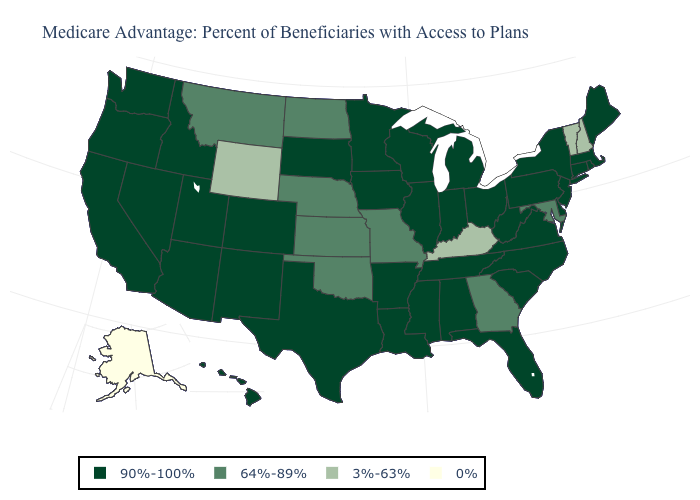Name the states that have a value in the range 0%?
Keep it brief. Alaska. What is the value of Massachusetts?
Quick response, please. 90%-100%. Name the states that have a value in the range 0%?
Short answer required. Alaska. What is the lowest value in the South?
Answer briefly. 3%-63%. Among the states that border Michigan , which have the lowest value?
Keep it brief. Indiana, Ohio, Wisconsin. Name the states that have a value in the range 90%-100%?
Keep it brief. Alabama, Arkansas, Arizona, California, Colorado, Connecticut, Delaware, Florida, Hawaii, Iowa, Idaho, Illinois, Indiana, Louisiana, Massachusetts, Maine, Michigan, Minnesota, Mississippi, North Carolina, New Jersey, New Mexico, Nevada, New York, Ohio, Oregon, Pennsylvania, Rhode Island, South Carolina, South Dakota, Tennessee, Texas, Utah, Virginia, Washington, Wisconsin, West Virginia. What is the value of South Carolina?
Short answer required. 90%-100%. Does the first symbol in the legend represent the smallest category?
Be succinct. No. Name the states that have a value in the range 64%-89%?
Write a very short answer. Georgia, Kansas, Maryland, Missouri, Montana, North Dakota, Nebraska, Oklahoma. Does California have the lowest value in the USA?
Write a very short answer. No. How many symbols are there in the legend?
Be succinct. 4. Is the legend a continuous bar?
Quick response, please. No. What is the lowest value in the USA?
Concise answer only. 0%. Name the states that have a value in the range 90%-100%?
Short answer required. Alabama, Arkansas, Arizona, California, Colorado, Connecticut, Delaware, Florida, Hawaii, Iowa, Idaho, Illinois, Indiana, Louisiana, Massachusetts, Maine, Michigan, Minnesota, Mississippi, North Carolina, New Jersey, New Mexico, Nevada, New York, Ohio, Oregon, Pennsylvania, Rhode Island, South Carolina, South Dakota, Tennessee, Texas, Utah, Virginia, Washington, Wisconsin, West Virginia. What is the value of Wisconsin?
Quick response, please. 90%-100%. 